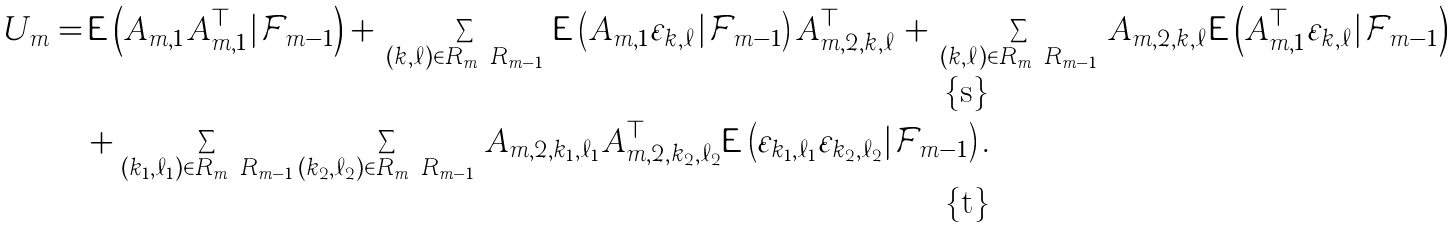<formula> <loc_0><loc_0><loc_500><loc_500>U _ { m } = & \, { \mathsf E } \left ( A _ { m , 1 } A _ { m , 1 } ^ { \top } | { \mathcal { F } } _ { m - 1 } \right ) + \, \sum _ { ( k , \ell ) \in R _ { m } \ R _ { m - 1 } } \, { \mathsf E } \left ( A _ { m , 1 } \varepsilon _ { k , \ell } | { \mathcal { F } } _ { m - 1 } \right ) A _ { m , 2 , k , \ell } ^ { \top } + \, \sum _ { ( k , \ell ) \in R _ { m } \ R _ { m - 1 } } \, A _ { m , 2 , k , \ell } { \mathsf E } \left ( A _ { m , 1 } ^ { \top } \varepsilon _ { k , \ell } | { \mathcal { F } } _ { m - 1 } \right ) \\ & + \sum _ { ( k _ { 1 } , \ell _ { 1 } ) \in R _ { m } \ R _ { m - 1 } } \sum _ { ( k _ { 2 } , \ell _ { 2 } ) \in R _ { m } \ R _ { m - 1 } } \, A _ { m , 2 , k _ { 1 } , \ell _ { 1 } } A _ { m , 2 , k _ { 2 } , \ell _ { 2 } } ^ { \top } { \mathsf E } \left ( \varepsilon _ { k _ { 1 } , \ell _ { 1 } } \varepsilon _ { k _ { 2 } , \ell _ { 2 } } | { \mathcal { F } } _ { m - 1 } \right ) .</formula> 